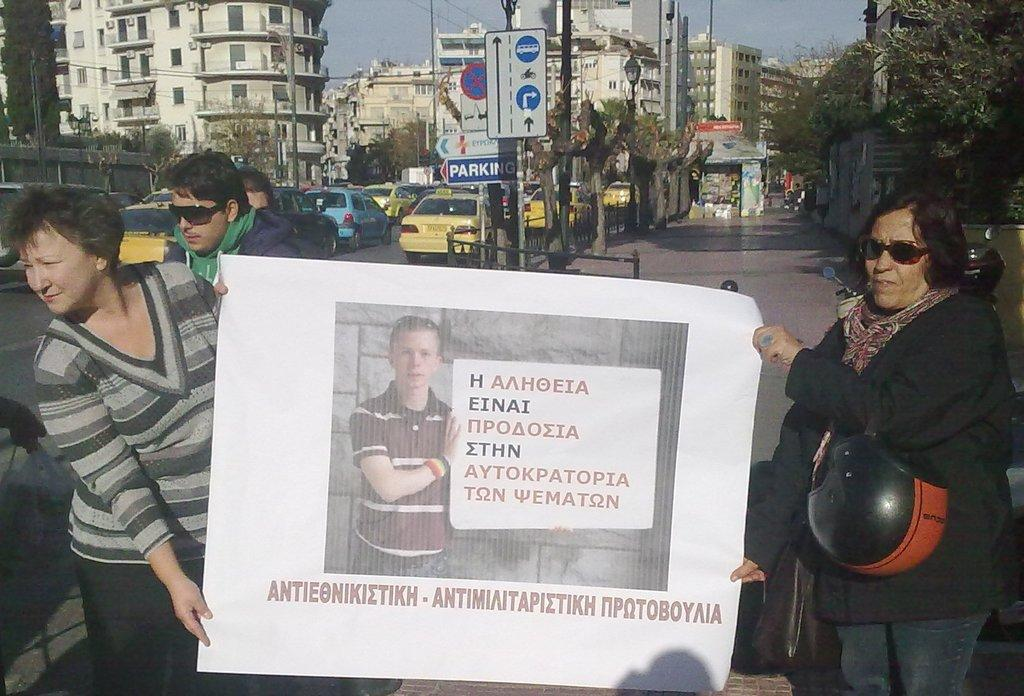How many people can be seen in the image? There are people in the image, but the exact number is not specified. What are two people holding in the image? Two people are holding a poster with text and an image. What type of natural elements are present in the image? There are trees in the image. What type of man-made structures are present in the image? There are buildings in the image. What type of transportation is present in the image? Vehicles are present in the image. What type of vertical structures are present in the image? Poles are visible in the image. What type of informational displays are present in the image? Sign boards are in the image. What type of barrier is present in the image? A fence is present in the image. What substance is the father using to clean the women in the image? There is no mention of a father, women, or any cleaning substance in the image. 